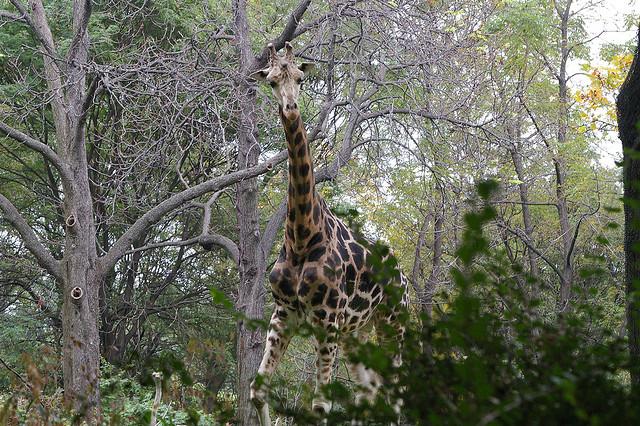What is the color of the giraffe?
Write a very short answer. Brown. Can this animal fly?
Quick response, please. No. Is the animal in a cage?
Keep it brief. No. What is the animal shown?
Write a very short answer. Giraffe. What kind of animal is this?
Give a very brief answer. Giraffe. Does this animal have a trunk?
Concise answer only. No. Did he fall?
Be succinct. No. Are there leaves on the tree?
Be succinct. No. What is the giraffe doing?
Be succinct. Walking. What is the giraffe looking at?
Keep it brief. Camera. Is there another animal besides the giraffe?
Give a very brief answer. No. Is this giraffe in the wild?
Answer briefly. Yes. Are the trees bare?
Write a very short answer. Yes. What type of animal is this?
Concise answer only. Giraffe. What season might it be?
Give a very brief answer. Fall. 